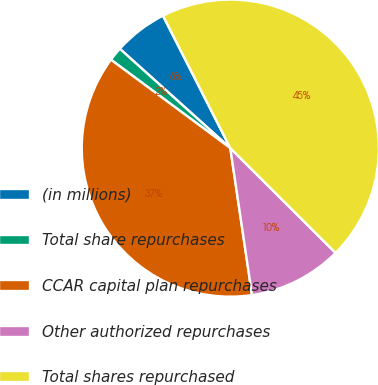<chart> <loc_0><loc_0><loc_500><loc_500><pie_chart><fcel>(in millions)<fcel>Total share repurchases<fcel>CCAR capital plan repurchases<fcel>Other authorized repurchases<fcel>Total shares repurchased<nl><fcel>5.86%<fcel>1.51%<fcel>37.48%<fcel>10.2%<fcel>44.95%<nl></chart> 